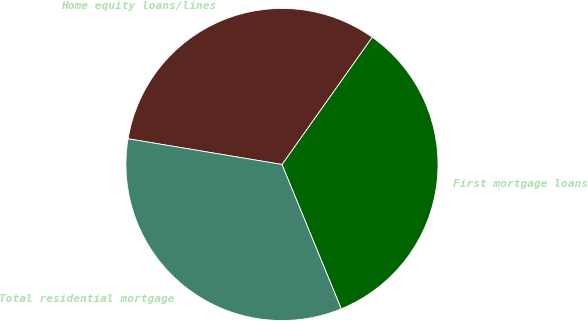<chart> <loc_0><loc_0><loc_500><loc_500><pie_chart><fcel>First mortgage loans<fcel>Home equity loans/lines<fcel>Total residential mortgage<nl><fcel>33.99%<fcel>32.18%<fcel>33.83%<nl></chart> 